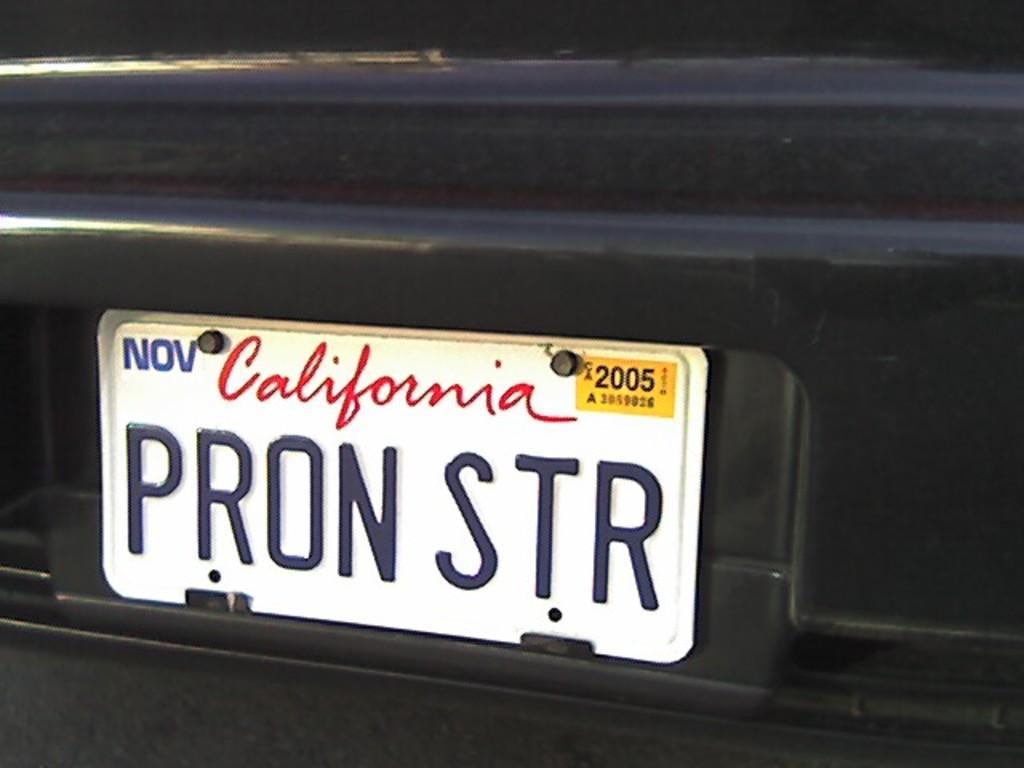Describe this image in one or two sentences. In the picture we can see a vehicle which is black in color and a number plate to it and written on it as California PRON STR. 